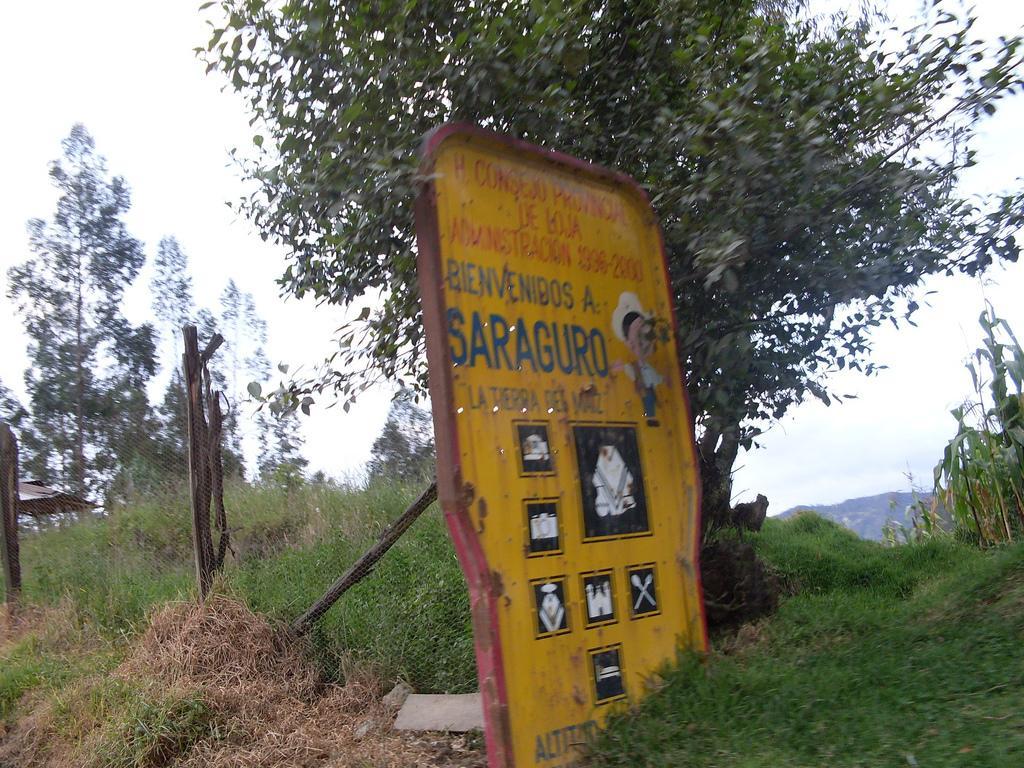Could you give a brief overview of what you see in this image? This image is taken outdoors. At the bottom of the image there is a ground with grass on it. In the middle of the image there is a board with a text and a few images on it and there is a net. In the background there are many trees and plants. At the top of the image there is a sky. 